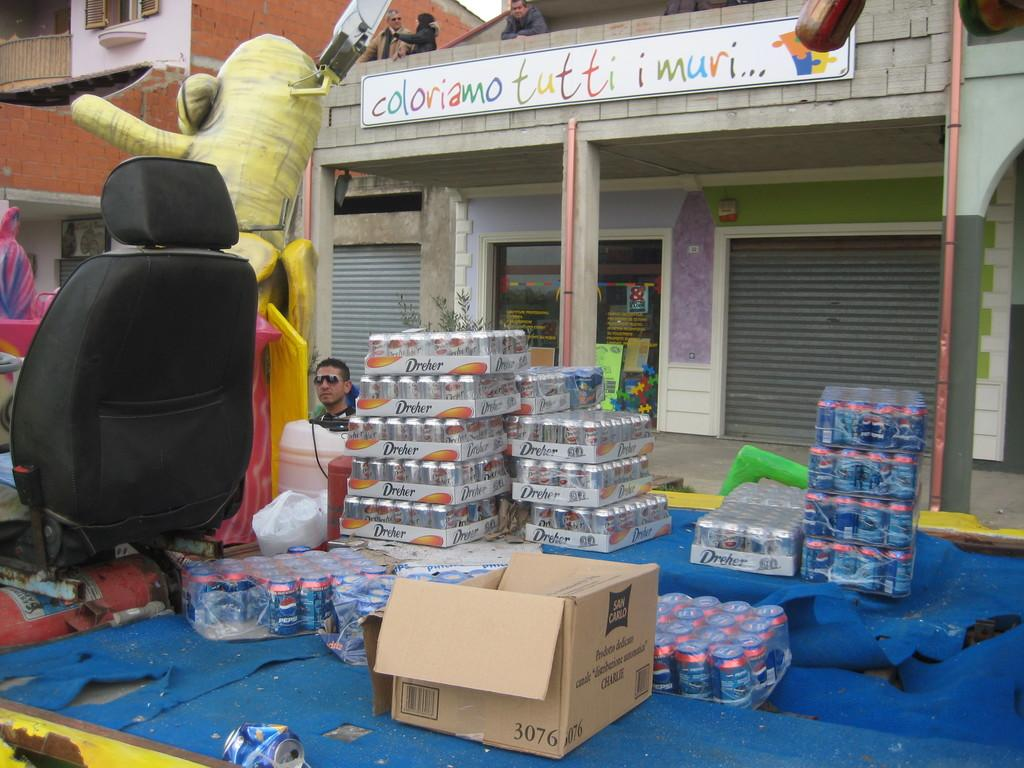<image>
Render a clear and concise summary of the photo. Several cans of drink, many of which are made by Pepsi. 